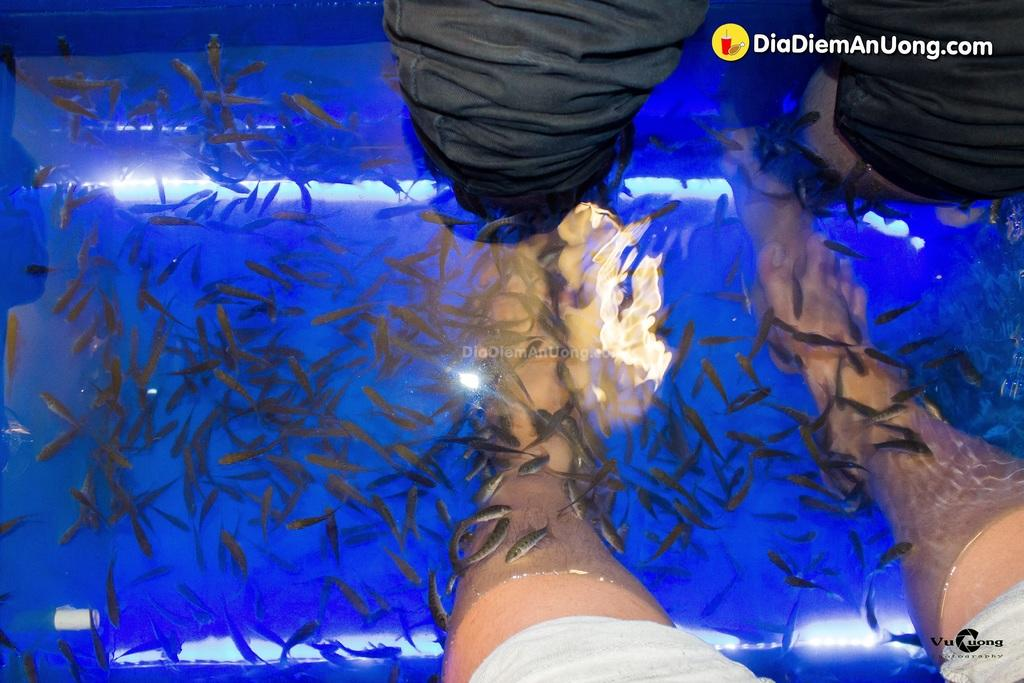What type of pedicure is being performed in the image? There is a fish pedicure in the image. Whose legs can be seen in the image? Two people's legs are visible in the image. What is the medium in which the pedicure is taking place? There is water in the image. What creatures are involved in the pedicure? There are fishes in the image. What type of scarf is being used to kick the fishes in the image? There is no scarf or kicking action present in the image. What sense is being stimulated by the fishes in the image? The fish pedicure is primarily focused on the sense of touch, as the fishes are nibbling on the people's feet. 